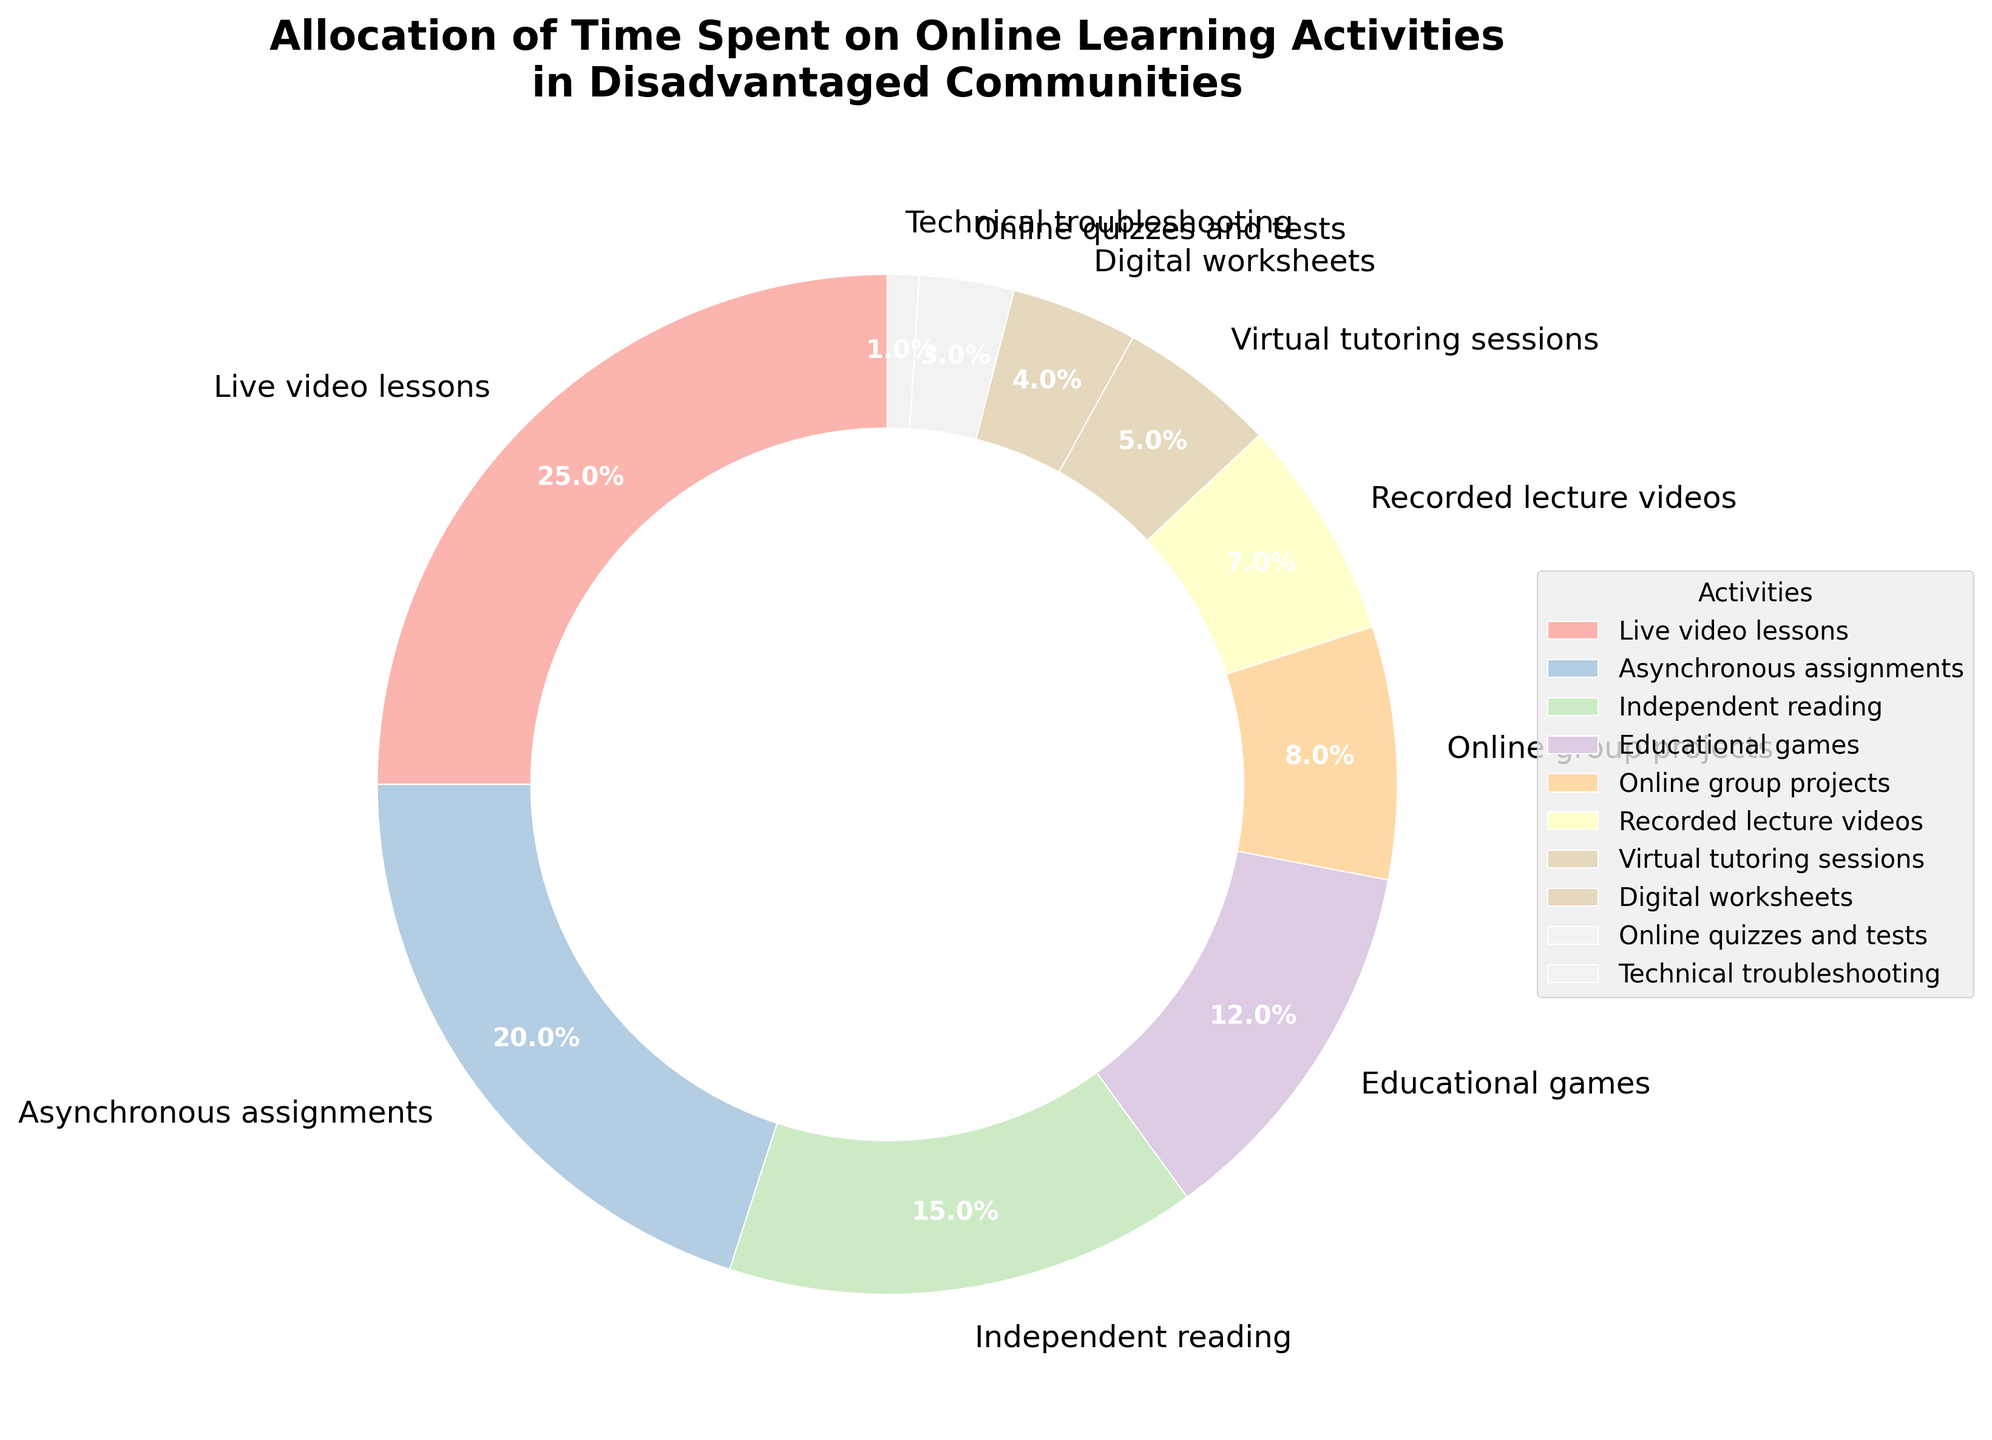Which activity takes up the largest percentage of time? The activity with the highest percentage slice is identified by the size of the wedge in the pie chart. In this case, "Live video lessons" occupies the largest wedge.
Answer: Live video lessons Which activities collectively take up less time than Independent reading? Adding the percentages of activities smaller than 15% which is the percentage for Independent reading; Educational games (12%), Online group projects (8%), Recorded lecture videos (7%), Virtual tutoring sessions (5%), Digital worksheets (4%), Online quizzes and tests (3%), Technical troubleshooting (1%). Total = 12 + 8 + 7 + 5 + 4 + 3 + 1 = 40.
Answer: Yes What is the ratio of time spent on Live video lessons to Recorded lecture videos? Live video lessons take up 25% of the time while Recorded lecture videos take up 7%. The ratio is 25:7.
Answer: 25:7 What fraction of the total time do Educational games and Online group projects combined take up? Adding the percentages for Educational games (12%) and Online group projects (8%), we get 12 + 8 = 20. Therefore, they take up 20% of the total time.
Answer: 20% How much more time is spent on Asynchronous assignments compared to Digital worksheets? Asynchronous assignments account for 20% of the time, and Digital worksheets account for 4%. The difference is 20 - 4 = 16%.
Answer: 16% Which color wedge represents Online quizzes and tests? Online quizzes and tests are represented by a specific color wedge in the pie chart with the label "Online quizzes and tests". By looking for this label, we can identify the associated color.
Answer: [Answer based on the specific color in the rendered figure, e.g., "light green"] Are Digital worksheets and Technical troubleshooting’s combined time allocation more than Independent reading? Adding the percentages of Digital worksheets (4%) and Technical troubleshooting (1%) results in 4 + 1 = 5%, which is less than Independent reading at 15%.
Answer: No How does the allocation of time for Online group projects compare to Virtual tutoring sessions? Online group projects take up 8% of the total time, while Virtual tutoring sessions take up 5%. Thus, Online group projects take up more time.
Answer: Online group projects take up more What is the average time allocation for Educational games, Online group projects, and Virtual tutoring sessions? Adding the percentages for Educational games (12%), Online group projects (8%), and Virtual tutoring sessions (5%) and then dividing by the number of activities, we get (12 + 8 + 5) / 3 = 25 / 3 ≈ 8.3%.
Answer: 8.3% 